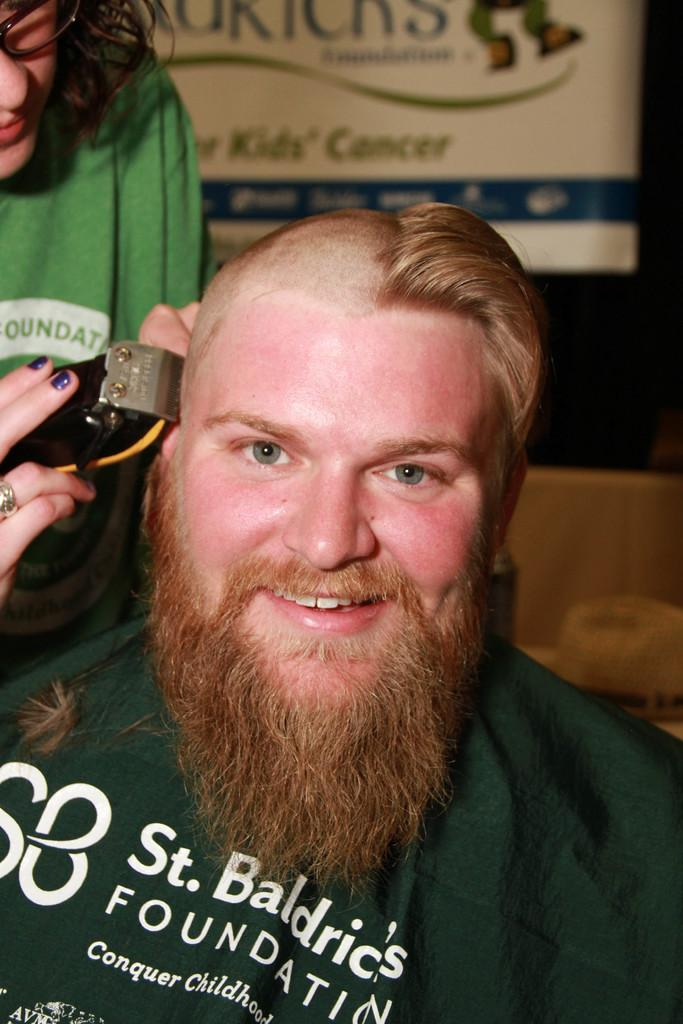Who is present in the image? There is a man and a woman in the image. What is the man doing in the image? The man is smiling in the image. What is the woman holding in the image? The woman is holding an electrical device in the image. What can be seen on a surface in the background of the image? There is a hat on a surface in the background of the image. What is present in the background of the image? There is a banner in the background of the image. How would you describe the lighting in the image? The background is dark in the image. What type of picture is the woman taking in the image? There is no indication in the image that the woman is taking a picture. 